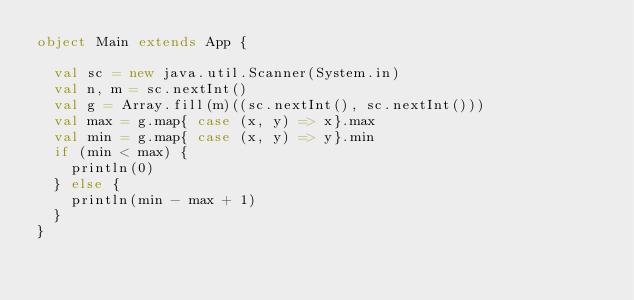Convert code to text. <code><loc_0><loc_0><loc_500><loc_500><_Scala_>object Main extends App {
 
  val sc = new java.util.Scanner(System.in) 
  val n, m = sc.nextInt()
  val g = Array.fill(m)((sc.nextInt(), sc.nextInt()))
  val max = g.map{ case (x, y) => x}.max
  val min = g.map{ case (x, y) => y}.min
  if (min < max) {
    println(0)
  } else {
    println(min - max + 1)
  }
}</code> 